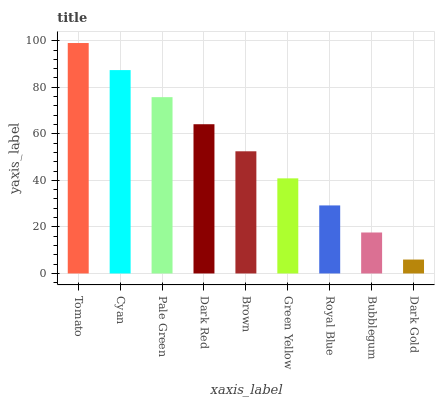Is Dark Gold the minimum?
Answer yes or no. Yes. Is Tomato the maximum?
Answer yes or no. Yes. Is Cyan the minimum?
Answer yes or no. No. Is Cyan the maximum?
Answer yes or no. No. Is Tomato greater than Cyan?
Answer yes or no. Yes. Is Cyan less than Tomato?
Answer yes or no. Yes. Is Cyan greater than Tomato?
Answer yes or no. No. Is Tomato less than Cyan?
Answer yes or no. No. Is Brown the high median?
Answer yes or no. Yes. Is Brown the low median?
Answer yes or no. Yes. Is Cyan the high median?
Answer yes or no. No. Is Dark Red the low median?
Answer yes or no. No. 